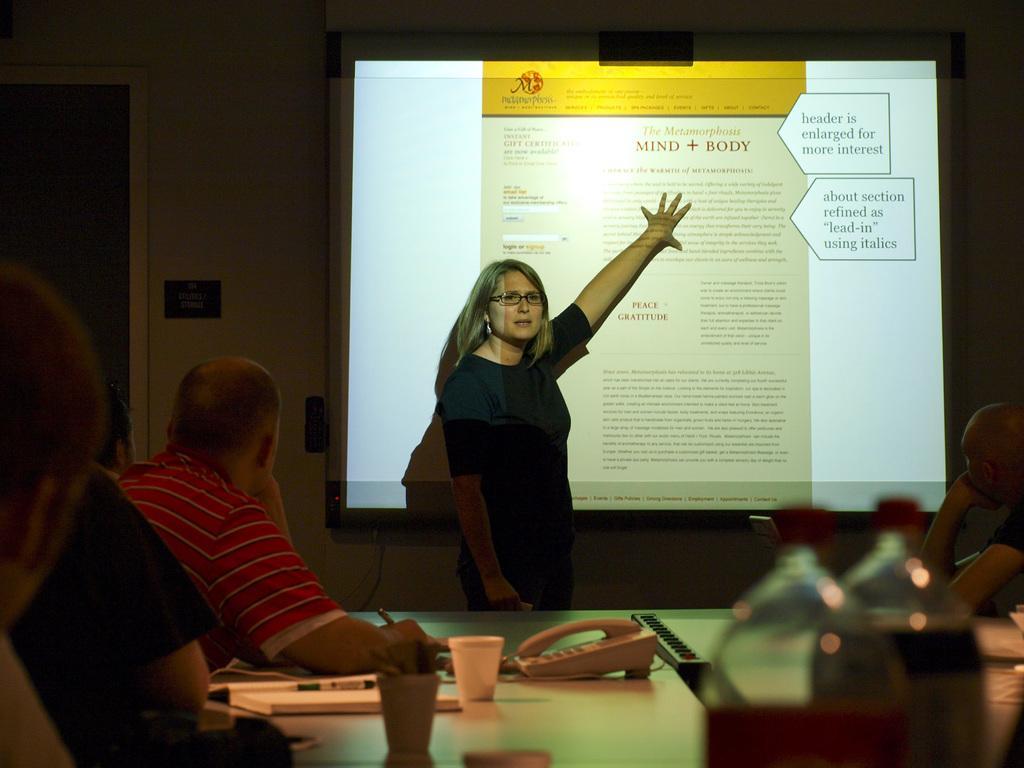Please provide a concise description of this image. In this image there is a table on that table there are bottles,glasses,and a telephone and some people are sitting on the table and a woman standing and explaining something on projector and in the background there is a wall and there is a switch box of black color. 